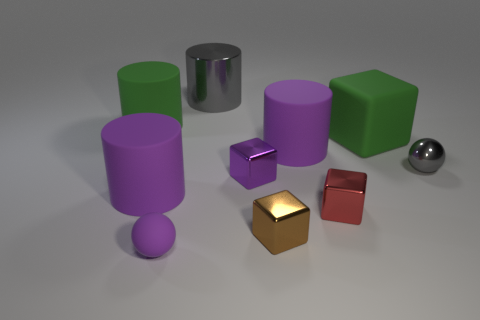Subtract all tiny purple blocks. How many blocks are left? 3 Subtract all red cubes. How many purple cylinders are left? 2 Add 3 green rubber objects. How many green rubber objects are left? 5 Add 5 large gray cylinders. How many large gray cylinders exist? 6 Subtract all purple spheres. How many spheres are left? 1 Subtract 2 purple cylinders. How many objects are left? 8 Subtract all spheres. How many objects are left? 8 Subtract 1 cylinders. How many cylinders are left? 3 Subtract all blue cylinders. Subtract all yellow cubes. How many cylinders are left? 4 Subtract all yellow metallic balls. Subtract all spheres. How many objects are left? 8 